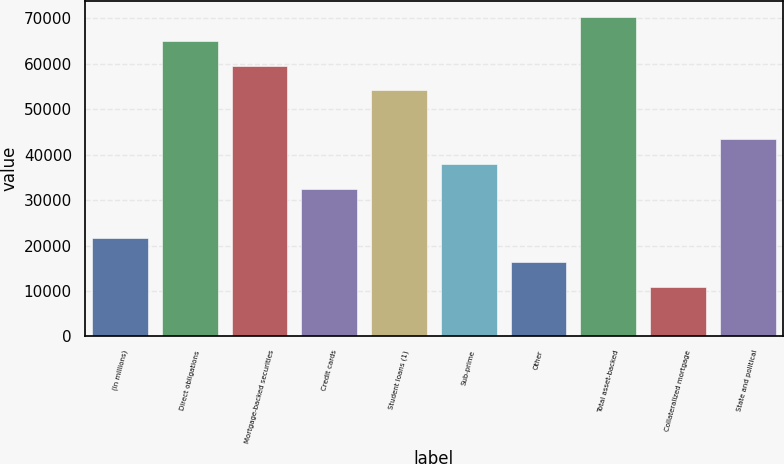Convert chart to OTSL. <chart><loc_0><loc_0><loc_500><loc_500><bar_chart><fcel>(In millions)<fcel>Direct obligations<fcel>Mortgage-backed securities<fcel>Credit cards<fcel>Student loans (1)<fcel>Sub-prime<fcel>Other<fcel>Total asset-backed<fcel>Collateralized mortgage<fcel>State and political<nl><fcel>21739<fcel>64971<fcel>59567<fcel>32547<fcel>54163<fcel>37951<fcel>16335<fcel>70375<fcel>10931<fcel>43355<nl></chart> 